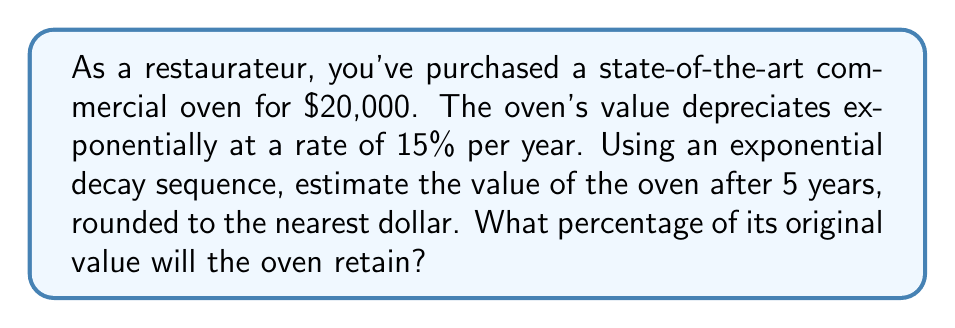Could you help me with this problem? To solve this problem, we'll use the exponential decay formula:

$$A = P(1-r)^t$$

Where:
$A$ = Final amount
$P$ = Initial principal balance
$r$ = Decay rate (as a decimal)
$t$ = Time in years

Step 1: Identify the given values
$P = $20,000$ (initial value)
$r = 15\% = 0.15$ (decay rate)
$t = 5$ years

Step 2: Plug the values into the formula
$$A = 20,000(1-0.15)^5$$

Step 3: Simplify
$$A = 20,000(0.85)^5$$

Step 4: Calculate
$$A = 20,000 \times 0.4437 = 8,874.02$$

Step 5: Round to the nearest dollar
$A \approx $8,874$

Step 6: Calculate the percentage of original value retained
$$\text{Percentage retained} = \frac{\text{Final value}}{\text{Initial value}} \times 100\%$$
$$= \frac{8,874}{20,000} \times 100\% = 44.37\%$$

Therefore, after 5 years, the oven will be worth approximately $8,874 and will retain about 44.37% of its original value.
Answer: $8,874; 44.37% 